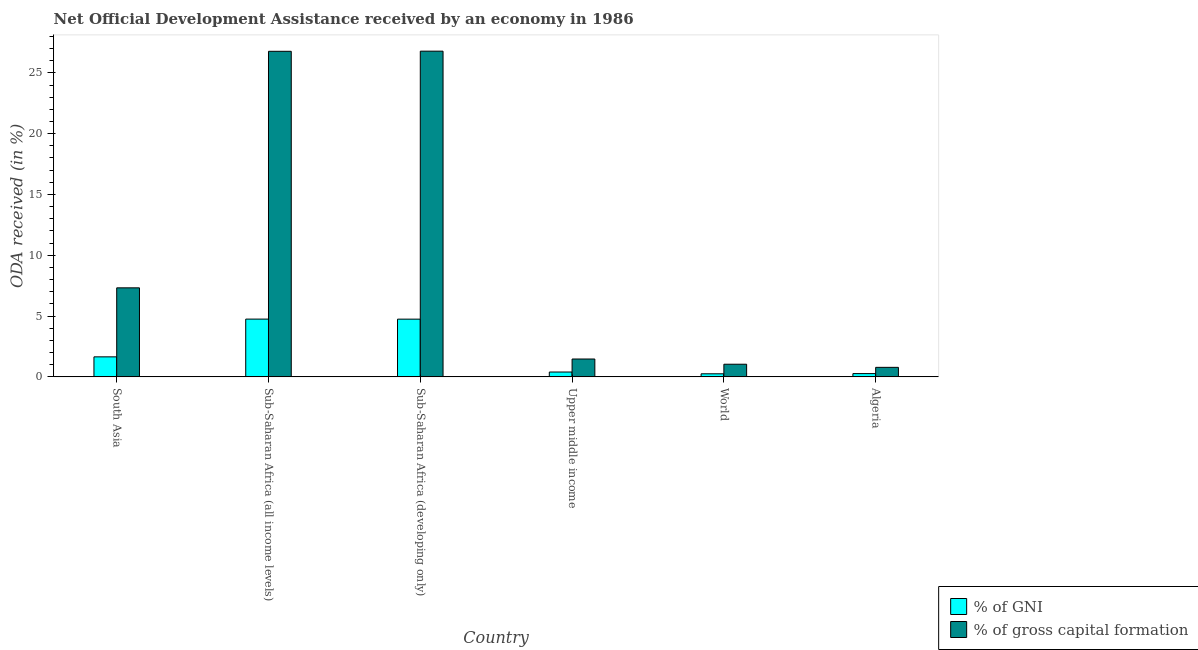Are the number of bars per tick equal to the number of legend labels?
Your answer should be very brief. Yes. Are the number of bars on each tick of the X-axis equal?
Make the answer very short. Yes. How many bars are there on the 5th tick from the right?
Give a very brief answer. 2. What is the label of the 2nd group of bars from the left?
Offer a very short reply. Sub-Saharan Africa (all income levels). What is the oda received as percentage of gross capital formation in Sub-Saharan Africa (all income levels)?
Offer a terse response. 26.77. Across all countries, what is the maximum oda received as percentage of gross capital formation?
Give a very brief answer. 26.78. Across all countries, what is the minimum oda received as percentage of gni?
Offer a very short reply. 0.25. In which country was the oda received as percentage of gni maximum?
Your answer should be very brief. Sub-Saharan Africa (all income levels). What is the total oda received as percentage of gni in the graph?
Offer a terse response. 12.06. What is the difference between the oda received as percentage of gni in Sub-Saharan Africa (developing only) and that in Upper middle income?
Ensure brevity in your answer.  4.35. What is the difference between the oda received as percentage of gross capital formation in Sub-Saharan Africa (developing only) and the oda received as percentage of gni in Upper middle income?
Provide a short and direct response. 26.38. What is the average oda received as percentage of gross capital formation per country?
Keep it short and to the point. 10.69. What is the difference between the oda received as percentage of gni and oda received as percentage of gross capital formation in Sub-Saharan Africa (developing only)?
Your answer should be very brief. -22.04. In how many countries, is the oda received as percentage of gross capital formation greater than 17 %?
Provide a succinct answer. 2. What is the ratio of the oda received as percentage of gni in Sub-Saharan Africa (all income levels) to that in Sub-Saharan Africa (developing only)?
Offer a very short reply. 1. What is the difference between the highest and the second highest oda received as percentage of gross capital formation?
Provide a succinct answer. 0.01. What is the difference between the highest and the lowest oda received as percentage of gross capital formation?
Ensure brevity in your answer.  26. In how many countries, is the oda received as percentage of gni greater than the average oda received as percentage of gni taken over all countries?
Your answer should be compact. 2. Is the sum of the oda received as percentage of gross capital formation in Algeria and World greater than the maximum oda received as percentage of gni across all countries?
Your response must be concise. No. What does the 1st bar from the left in Upper middle income represents?
Make the answer very short. % of GNI. What does the 2nd bar from the right in Algeria represents?
Your answer should be very brief. % of GNI. How many bars are there?
Offer a terse response. 12. Are all the bars in the graph horizontal?
Your answer should be very brief. No. What is the difference between two consecutive major ticks on the Y-axis?
Your answer should be compact. 5. Are the values on the major ticks of Y-axis written in scientific E-notation?
Ensure brevity in your answer.  No. Does the graph contain grids?
Keep it short and to the point. No. Where does the legend appear in the graph?
Your answer should be very brief. Bottom right. How many legend labels are there?
Provide a short and direct response. 2. How are the legend labels stacked?
Ensure brevity in your answer.  Vertical. What is the title of the graph?
Keep it short and to the point. Net Official Development Assistance received by an economy in 1986. Does "Male labor force" appear as one of the legend labels in the graph?
Give a very brief answer. No. What is the label or title of the X-axis?
Ensure brevity in your answer.  Country. What is the label or title of the Y-axis?
Offer a terse response. ODA received (in %). What is the ODA received (in %) of % of GNI in South Asia?
Provide a short and direct response. 1.65. What is the ODA received (in %) in % of gross capital formation in South Asia?
Offer a terse response. 7.32. What is the ODA received (in %) of % of GNI in Sub-Saharan Africa (all income levels)?
Your response must be concise. 4.75. What is the ODA received (in %) of % of gross capital formation in Sub-Saharan Africa (all income levels)?
Your response must be concise. 26.77. What is the ODA received (in %) of % of GNI in Sub-Saharan Africa (developing only)?
Keep it short and to the point. 4.75. What is the ODA received (in %) in % of gross capital formation in Sub-Saharan Africa (developing only)?
Offer a very short reply. 26.78. What is the ODA received (in %) in % of GNI in Upper middle income?
Your answer should be compact. 0.4. What is the ODA received (in %) of % of gross capital formation in Upper middle income?
Provide a succinct answer. 1.47. What is the ODA received (in %) in % of GNI in World?
Your response must be concise. 0.25. What is the ODA received (in %) of % of gross capital formation in World?
Offer a very short reply. 1.04. What is the ODA received (in %) in % of GNI in Algeria?
Your response must be concise. 0.27. What is the ODA received (in %) in % of gross capital formation in Algeria?
Provide a short and direct response. 0.78. Across all countries, what is the maximum ODA received (in %) in % of GNI?
Give a very brief answer. 4.75. Across all countries, what is the maximum ODA received (in %) of % of gross capital formation?
Provide a succinct answer. 26.78. Across all countries, what is the minimum ODA received (in %) in % of GNI?
Your response must be concise. 0.25. Across all countries, what is the minimum ODA received (in %) of % of gross capital formation?
Ensure brevity in your answer.  0.78. What is the total ODA received (in %) of % of GNI in the graph?
Keep it short and to the point. 12.06. What is the total ODA received (in %) in % of gross capital formation in the graph?
Ensure brevity in your answer.  64.17. What is the difference between the ODA received (in %) in % of GNI in South Asia and that in Sub-Saharan Africa (all income levels)?
Your answer should be very brief. -3.1. What is the difference between the ODA received (in %) in % of gross capital formation in South Asia and that in Sub-Saharan Africa (all income levels)?
Your answer should be very brief. -19.45. What is the difference between the ODA received (in %) of % of GNI in South Asia and that in Sub-Saharan Africa (developing only)?
Offer a very short reply. -3.1. What is the difference between the ODA received (in %) of % of gross capital formation in South Asia and that in Sub-Saharan Africa (developing only)?
Provide a short and direct response. -19.46. What is the difference between the ODA received (in %) in % of GNI in South Asia and that in Upper middle income?
Your response must be concise. 1.25. What is the difference between the ODA received (in %) in % of gross capital formation in South Asia and that in Upper middle income?
Keep it short and to the point. 5.85. What is the difference between the ODA received (in %) of % of GNI in South Asia and that in World?
Provide a succinct answer. 1.39. What is the difference between the ODA received (in %) in % of gross capital formation in South Asia and that in World?
Provide a short and direct response. 6.28. What is the difference between the ODA received (in %) of % of GNI in South Asia and that in Algeria?
Your answer should be compact. 1.38. What is the difference between the ODA received (in %) in % of gross capital formation in South Asia and that in Algeria?
Keep it short and to the point. 6.54. What is the difference between the ODA received (in %) in % of GNI in Sub-Saharan Africa (all income levels) and that in Sub-Saharan Africa (developing only)?
Offer a very short reply. 0. What is the difference between the ODA received (in %) in % of gross capital formation in Sub-Saharan Africa (all income levels) and that in Sub-Saharan Africa (developing only)?
Make the answer very short. -0.01. What is the difference between the ODA received (in %) of % of GNI in Sub-Saharan Africa (all income levels) and that in Upper middle income?
Your answer should be compact. 4.35. What is the difference between the ODA received (in %) of % of gross capital formation in Sub-Saharan Africa (all income levels) and that in Upper middle income?
Ensure brevity in your answer.  25.3. What is the difference between the ODA received (in %) of % of GNI in Sub-Saharan Africa (all income levels) and that in World?
Your answer should be very brief. 4.5. What is the difference between the ODA received (in %) of % of gross capital formation in Sub-Saharan Africa (all income levels) and that in World?
Offer a terse response. 25.73. What is the difference between the ODA received (in %) of % of GNI in Sub-Saharan Africa (all income levels) and that in Algeria?
Offer a terse response. 4.48. What is the difference between the ODA received (in %) of % of gross capital formation in Sub-Saharan Africa (all income levels) and that in Algeria?
Provide a succinct answer. 25.99. What is the difference between the ODA received (in %) in % of GNI in Sub-Saharan Africa (developing only) and that in Upper middle income?
Keep it short and to the point. 4.35. What is the difference between the ODA received (in %) in % of gross capital formation in Sub-Saharan Africa (developing only) and that in Upper middle income?
Keep it short and to the point. 25.31. What is the difference between the ODA received (in %) of % of GNI in Sub-Saharan Africa (developing only) and that in World?
Make the answer very short. 4.49. What is the difference between the ODA received (in %) of % of gross capital formation in Sub-Saharan Africa (developing only) and that in World?
Offer a terse response. 25.74. What is the difference between the ODA received (in %) in % of GNI in Sub-Saharan Africa (developing only) and that in Algeria?
Provide a succinct answer. 4.48. What is the difference between the ODA received (in %) in % of gross capital formation in Sub-Saharan Africa (developing only) and that in Algeria?
Make the answer very short. 26. What is the difference between the ODA received (in %) in % of GNI in Upper middle income and that in World?
Your response must be concise. 0.15. What is the difference between the ODA received (in %) of % of gross capital formation in Upper middle income and that in World?
Make the answer very short. 0.43. What is the difference between the ODA received (in %) of % of GNI in Upper middle income and that in Algeria?
Make the answer very short. 0.13. What is the difference between the ODA received (in %) of % of gross capital formation in Upper middle income and that in Algeria?
Offer a terse response. 0.69. What is the difference between the ODA received (in %) in % of GNI in World and that in Algeria?
Make the answer very short. -0.02. What is the difference between the ODA received (in %) of % of gross capital formation in World and that in Algeria?
Offer a terse response. 0.26. What is the difference between the ODA received (in %) of % of GNI in South Asia and the ODA received (in %) of % of gross capital formation in Sub-Saharan Africa (all income levels)?
Your answer should be very brief. -25.13. What is the difference between the ODA received (in %) in % of GNI in South Asia and the ODA received (in %) in % of gross capital formation in Sub-Saharan Africa (developing only)?
Give a very brief answer. -25.14. What is the difference between the ODA received (in %) in % of GNI in South Asia and the ODA received (in %) in % of gross capital formation in Upper middle income?
Offer a very short reply. 0.18. What is the difference between the ODA received (in %) of % of GNI in South Asia and the ODA received (in %) of % of gross capital formation in World?
Offer a very short reply. 0.61. What is the difference between the ODA received (in %) of % of GNI in South Asia and the ODA received (in %) of % of gross capital formation in Algeria?
Offer a very short reply. 0.86. What is the difference between the ODA received (in %) of % of GNI in Sub-Saharan Africa (all income levels) and the ODA received (in %) of % of gross capital formation in Sub-Saharan Africa (developing only)?
Ensure brevity in your answer.  -22.03. What is the difference between the ODA received (in %) in % of GNI in Sub-Saharan Africa (all income levels) and the ODA received (in %) in % of gross capital formation in Upper middle income?
Your answer should be very brief. 3.28. What is the difference between the ODA received (in %) in % of GNI in Sub-Saharan Africa (all income levels) and the ODA received (in %) in % of gross capital formation in World?
Give a very brief answer. 3.71. What is the difference between the ODA received (in %) in % of GNI in Sub-Saharan Africa (all income levels) and the ODA received (in %) in % of gross capital formation in Algeria?
Give a very brief answer. 3.97. What is the difference between the ODA received (in %) in % of GNI in Sub-Saharan Africa (developing only) and the ODA received (in %) in % of gross capital formation in Upper middle income?
Keep it short and to the point. 3.28. What is the difference between the ODA received (in %) in % of GNI in Sub-Saharan Africa (developing only) and the ODA received (in %) in % of gross capital formation in World?
Your answer should be compact. 3.71. What is the difference between the ODA received (in %) in % of GNI in Sub-Saharan Africa (developing only) and the ODA received (in %) in % of gross capital formation in Algeria?
Provide a succinct answer. 3.96. What is the difference between the ODA received (in %) of % of GNI in Upper middle income and the ODA received (in %) of % of gross capital formation in World?
Keep it short and to the point. -0.64. What is the difference between the ODA received (in %) of % of GNI in Upper middle income and the ODA received (in %) of % of gross capital formation in Algeria?
Provide a short and direct response. -0.38. What is the difference between the ODA received (in %) in % of GNI in World and the ODA received (in %) in % of gross capital formation in Algeria?
Provide a short and direct response. -0.53. What is the average ODA received (in %) of % of GNI per country?
Keep it short and to the point. 2.01. What is the average ODA received (in %) of % of gross capital formation per country?
Your answer should be compact. 10.69. What is the difference between the ODA received (in %) in % of GNI and ODA received (in %) in % of gross capital formation in South Asia?
Provide a short and direct response. -5.67. What is the difference between the ODA received (in %) of % of GNI and ODA received (in %) of % of gross capital formation in Sub-Saharan Africa (all income levels)?
Offer a very short reply. -22.02. What is the difference between the ODA received (in %) in % of GNI and ODA received (in %) in % of gross capital formation in Sub-Saharan Africa (developing only)?
Ensure brevity in your answer.  -22.04. What is the difference between the ODA received (in %) of % of GNI and ODA received (in %) of % of gross capital formation in Upper middle income?
Provide a short and direct response. -1.07. What is the difference between the ODA received (in %) in % of GNI and ODA received (in %) in % of gross capital formation in World?
Provide a short and direct response. -0.79. What is the difference between the ODA received (in %) of % of GNI and ODA received (in %) of % of gross capital formation in Algeria?
Keep it short and to the point. -0.51. What is the ratio of the ODA received (in %) in % of GNI in South Asia to that in Sub-Saharan Africa (all income levels)?
Your answer should be very brief. 0.35. What is the ratio of the ODA received (in %) in % of gross capital formation in South Asia to that in Sub-Saharan Africa (all income levels)?
Provide a succinct answer. 0.27. What is the ratio of the ODA received (in %) of % of GNI in South Asia to that in Sub-Saharan Africa (developing only)?
Ensure brevity in your answer.  0.35. What is the ratio of the ODA received (in %) of % of gross capital formation in South Asia to that in Sub-Saharan Africa (developing only)?
Your answer should be compact. 0.27. What is the ratio of the ODA received (in %) of % of GNI in South Asia to that in Upper middle income?
Keep it short and to the point. 4.12. What is the ratio of the ODA received (in %) of % of gross capital formation in South Asia to that in Upper middle income?
Offer a terse response. 4.98. What is the ratio of the ODA received (in %) in % of GNI in South Asia to that in World?
Provide a succinct answer. 6.51. What is the ratio of the ODA received (in %) of % of gross capital formation in South Asia to that in World?
Your answer should be compact. 7.04. What is the ratio of the ODA received (in %) in % of GNI in South Asia to that in Algeria?
Provide a short and direct response. 6.13. What is the ratio of the ODA received (in %) of % of gross capital formation in South Asia to that in Algeria?
Make the answer very short. 9.35. What is the ratio of the ODA received (in %) of % of GNI in Sub-Saharan Africa (all income levels) to that in Sub-Saharan Africa (developing only)?
Your answer should be very brief. 1. What is the ratio of the ODA received (in %) in % of gross capital formation in Sub-Saharan Africa (all income levels) to that in Sub-Saharan Africa (developing only)?
Your answer should be compact. 1. What is the ratio of the ODA received (in %) of % of GNI in Sub-Saharan Africa (all income levels) to that in Upper middle income?
Keep it short and to the point. 11.9. What is the ratio of the ODA received (in %) of % of gross capital formation in Sub-Saharan Africa (all income levels) to that in Upper middle income?
Provide a short and direct response. 18.22. What is the ratio of the ODA received (in %) of % of GNI in Sub-Saharan Africa (all income levels) to that in World?
Ensure brevity in your answer.  18.79. What is the ratio of the ODA received (in %) of % of gross capital formation in Sub-Saharan Africa (all income levels) to that in World?
Your answer should be compact. 25.74. What is the ratio of the ODA received (in %) in % of GNI in Sub-Saharan Africa (all income levels) to that in Algeria?
Your answer should be very brief. 17.68. What is the ratio of the ODA received (in %) of % of gross capital formation in Sub-Saharan Africa (all income levels) to that in Algeria?
Offer a terse response. 34.2. What is the ratio of the ODA received (in %) in % of GNI in Sub-Saharan Africa (developing only) to that in Upper middle income?
Provide a short and direct response. 11.89. What is the ratio of the ODA received (in %) of % of gross capital formation in Sub-Saharan Africa (developing only) to that in Upper middle income?
Ensure brevity in your answer.  18.23. What is the ratio of the ODA received (in %) in % of GNI in Sub-Saharan Africa (developing only) to that in World?
Provide a succinct answer. 18.78. What is the ratio of the ODA received (in %) of % of gross capital formation in Sub-Saharan Africa (developing only) to that in World?
Your answer should be compact. 25.75. What is the ratio of the ODA received (in %) in % of GNI in Sub-Saharan Africa (developing only) to that in Algeria?
Provide a succinct answer. 17.66. What is the ratio of the ODA received (in %) in % of gross capital formation in Sub-Saharan Africa (developing only) to that in Algeria?
Your answer should be compact. 34.21. What is the ratio of the ODA received (in %) in % of GNI in Upper middle income to that in World?
Your answer should be compact. 1.58. What is the ratio of the ODA received (in %) of % of gross capital formation in Upper middle income to that in World?
Your response must be concise. 1.41. What is the ratio of the ODA received (in %) of % of GNI in Upper middle income to that in Algeria?
Your answer should be very brief. 1.49. What is the ratio of the ODA received (in %) of % of gross capital formation in Upper middle income to that in Algeria?
Provide a succinct answer. 1.88. What is the ratio of the ODA received (in %) in % of GNI in World to that in Algeria?
Give a very brief answer. 0.94. What is the ratio of the ODA received (in %) in % of gross capital formation in World to that in Algeria?
Offer a very short reply. 1.33. What is the difference between the highest and the second highest ODA received (in %) of % of GNI?
Keep it short and to the point. 0. What is the difference between the highest and the second highest ODA received (in %) of % of gross capital formation?
Give a very brief answer. 0.01. What is the difference between the highest and the lowest ODA received (in %) of % of GNI?
Your answer should be compact. 4.5. What is the difference between the highest and the lowest ODA received (in %) in % of gross capital formation?
Your answer should be compact. 26. 